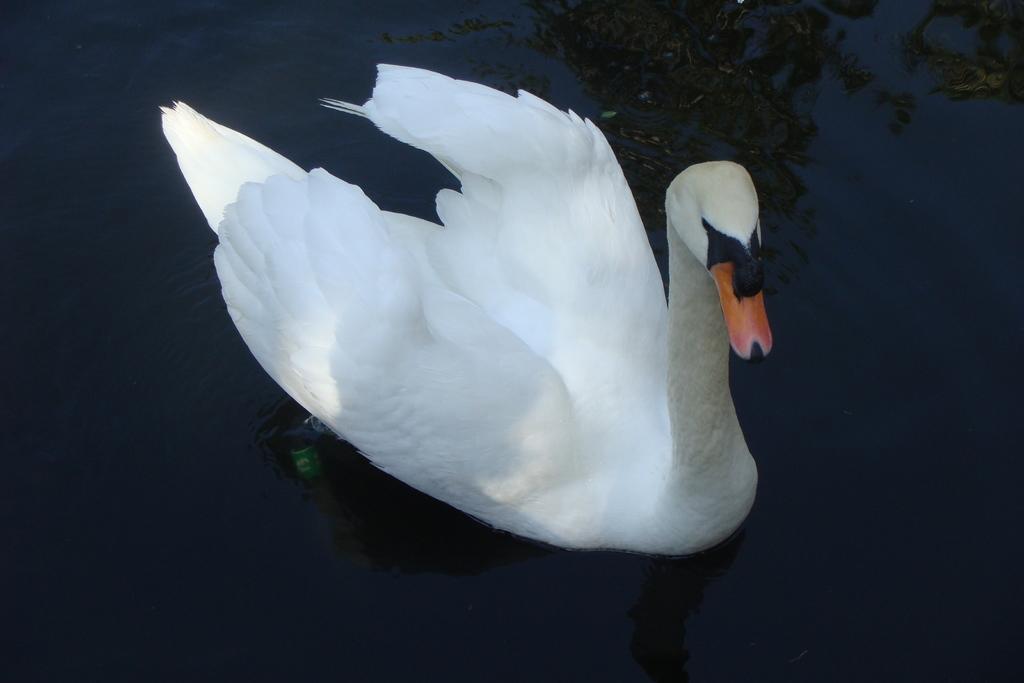Could you give a brief overview of what you see in this image? In this image I can see a bird on the water. The bird is in white, black and brown color. 